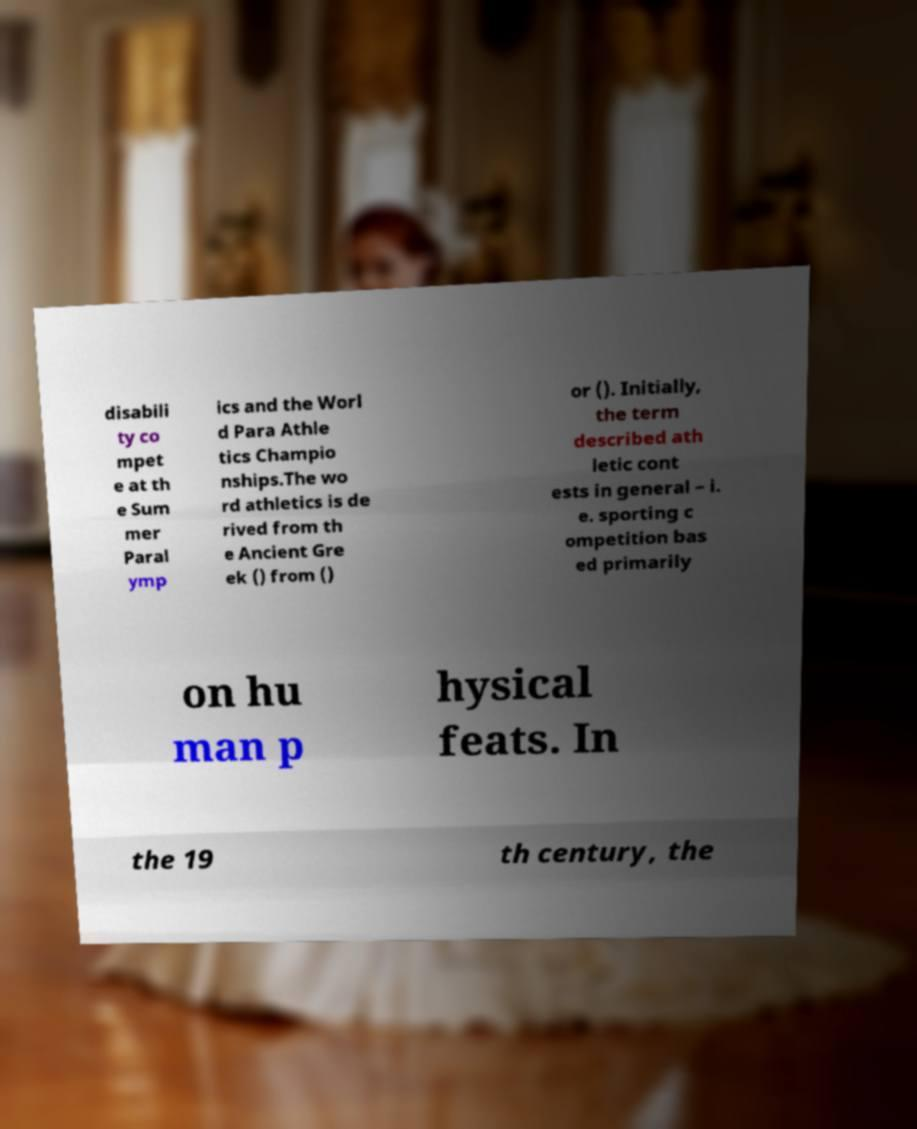Can you read and provide the text displayed in the image?This photo seems to have some interesting text. Can you extract and type it out for me? disabili ty co mpet e at th e Sum mer Paral ymp ics and the Worl d Para Athle tics Champio nships.The wo rd athletics is de rived from th e Ancient Gre ek () from () or (). Initially, the term described ath letic cont ests in general – i. e. sporting c ompetition bas ed primarily on hu man p hysical feats. In the 19 th century, the 